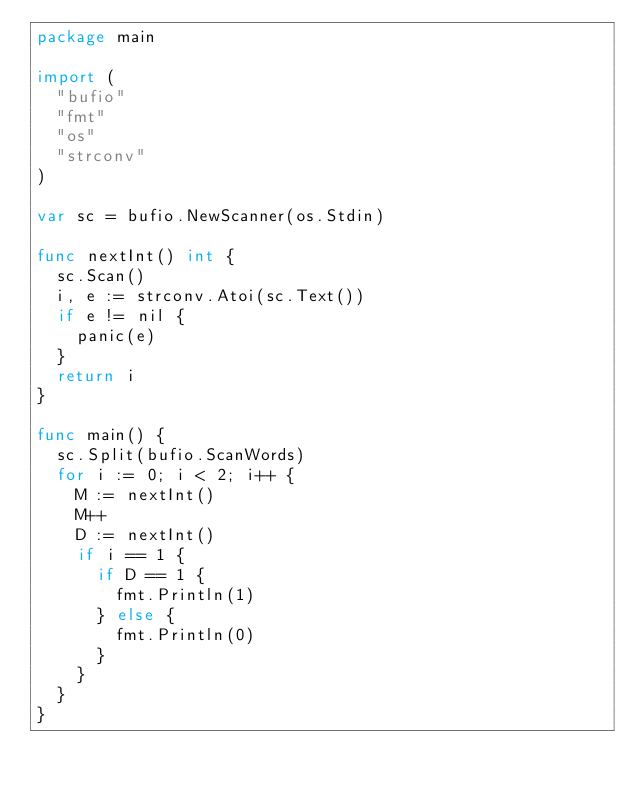Convert code to text. <code><loc_0><loc_0><loc_500><loc_500><_Go_>package main

import (
	"bufio"
	"fmt"
	"os"
	"strconv"
)

var sc = bufio.NewScanner(os.Stdin)

func nextInt() int {
	sc.Scan()
	i, e := strconv.Atoi(sc.Text())
	if e != nil {
		panic(e)
	}
	return i
}

func main() {
	sc.Split(bufio.ScanWords)
	for i := 0; i < 2; i++ {
		M := nextInt()
		M++
		D := nextInt()
		if i == 1 {
			if D == 1 {
				fmt.Println(1)
			} else {
				fmt.Println(0)
			}
		}
	}
}
</code> 